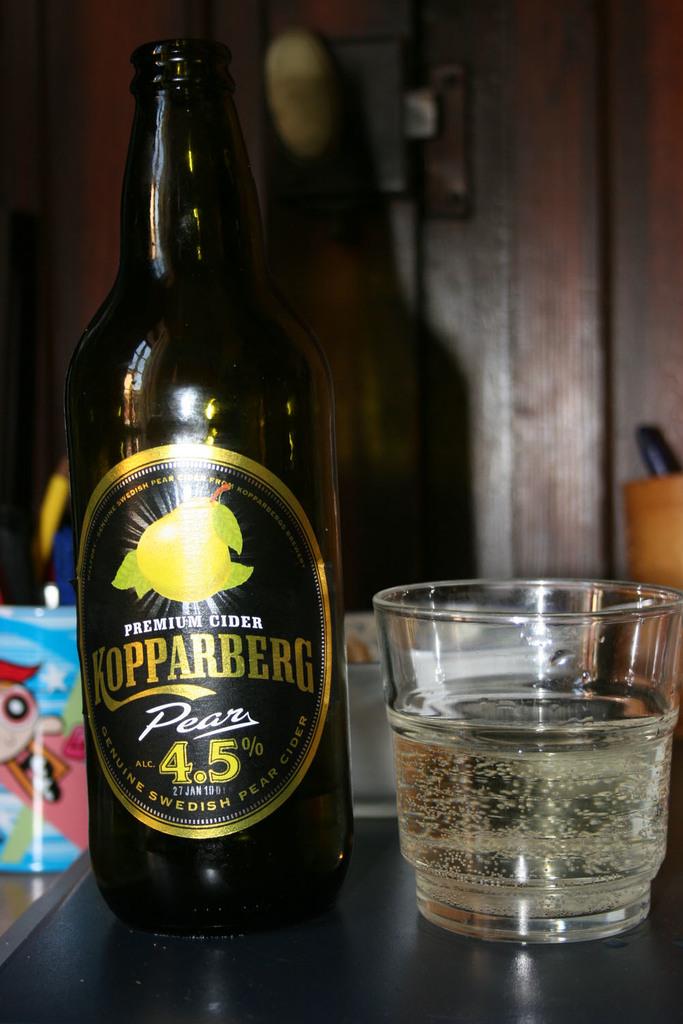What is the brand of beverage in the bottle?
Offer a terse response. Kopparberg. What kind of pears were used in this bottle?
Provide a short and direct response. Swedish. 